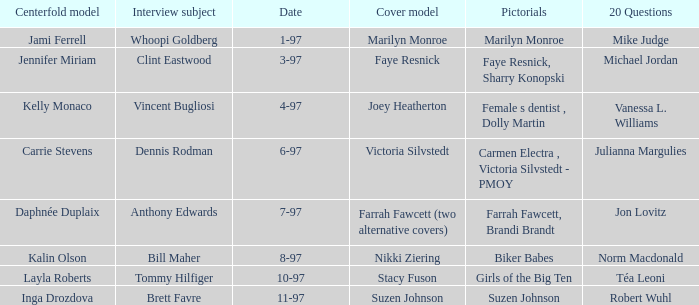When was Kalin Olson listed as  the centerfold model? 8-97. 